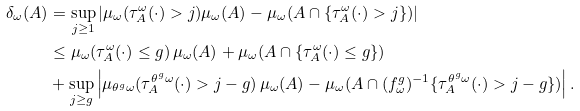<formula> <loc_0><loc_0><loc_500><loc_500>\delta _ { \omega } ( A ) & = \sup _ { j \geq 1 } | \mu _ { \omega } ( \tau _ { A } ^ { \omega } ( \cdot ) > j ) \mu _ { \omega } ( A ) - \mu _ { \omega } ( A \cap \{ \tau _ { A } ^ { \omega } ( \cdot ) > j \} ) | \\ & \leq \mu _ { \omega } ( \tau _ { A } ^ { \omega } ( \cdot ) \leq g ) \, \mu _ { \omega } ( A ) + \mu _ { \omega } ( A \cap \{ \tau _ { A } ^ { \omega } ( \cdot ) \leq g \} ) \\ & + \sup _ { j \geq g } \left | \mu _ { \theta ^ { g } \omega } ( \tau _ { A } ^ { \theta ^ { g } \omega } ( \cdot ) > j - g ) \, \mu _ { \omega } ( A ) - \mu _ { \omega } ( A \cap ( f _ { \omega } ^ { g } ) ^ { - 1 } \{ \tau _ { A } ^ { \theta ^ { g } \omega } ( \cdot ) > j - g \} ) \right | .</formula> 